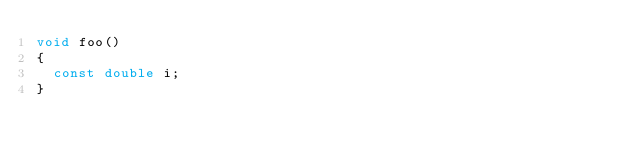<code> <loc_0><loc_0><loc_500><loc_500><_C_>void foo()
{
  const double i;
}
</code> 